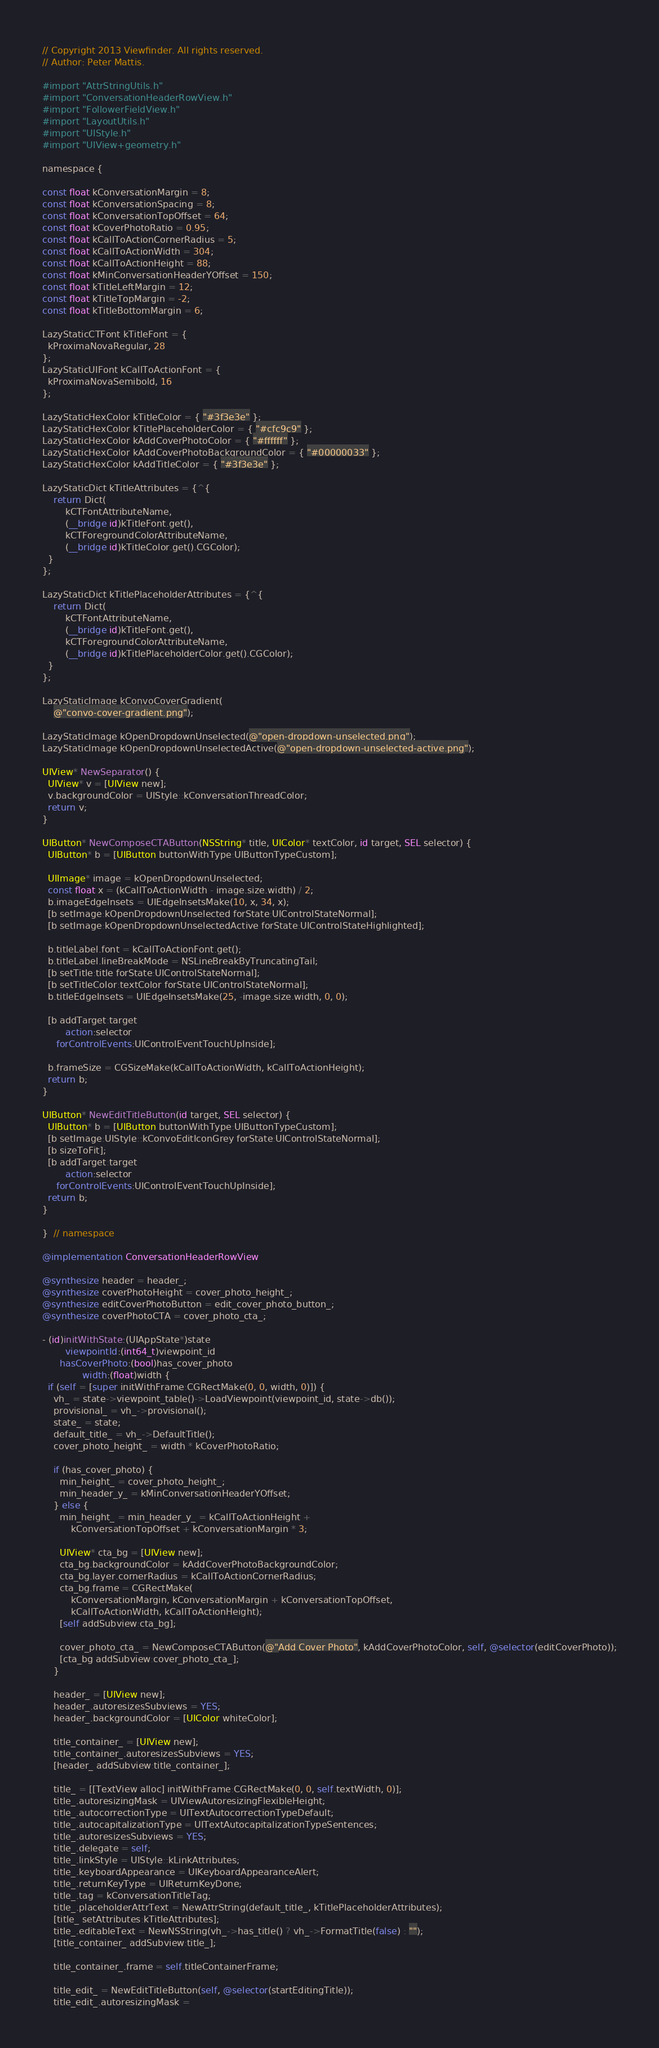Convert code to text. <code><loc_0><loc_0><loc_500><loc_500><_ObjectiveC_>// Copyright 2013 Viewfinder. All rights reserved.
// Author: Peter Mattis.

#import "AttrStringUtils.h"
#import "ConversationHeaderRowView.h"
#import "FollowerFieldView.h"
#import "LayoutUtils.h"
#import "UIStyle.h"
#import "UIView+geometry.h"

namespace {

const float kConversationMargin = 8;
const float kConversationSpacing = 8;
const float kConversationTopOffset = 64;
const float kCoverPhotoRatio = 0.95;
const float kCallToActionCornerRadius = 5;
const float kCallToActionWidth = 304;
const float kCallToActionHeight = 88;
const float kMinConversationHeaderYOffset = 150;
const float kTitleLeftMargin = 12;
const float kTitleTopMargin = -2;
const float kTitleBottomMargin = 6;

LazyStaticCTFont kTitleFont = {
  kProximaNovaRegular, 28
};
LazyStaticUIFont kCallToActionFont = {
  kProximaNovaSemibold, 16
};

LazyStaticHexColor kTitleColor = { "#3f3e3e" };
LazyStaticHexColor kTitlePlaceholderColor = { "#cfc9c9" };
LazyStaticHexColor kAddCoverPhotoColor = { "#ffffff" };
LazyStaticHexColor kAddCoverPhotoBackgroundColor = { "#00000033" };
LazyStaticHexColor kAddTitleColor = { "#3f3e3e" };

LazyStaticDict kTitleAttributes = {^{
    return Dict(
        kCTFontAttributeName,
        (__bridge id)kTitleFont.get(),
        kCTForegroundColorAttributeName,
        (__bridge id)kTitleColor.get().CGColor);
  }
};

LazyStaticDict kTitlePlaceholderAttributes = {^{
    return Dict(
        kCTFontAttributeName,
        (__bridge id)kTitleFont.get(),
        kCTForegroundColorAttributeName,
        (__bridge id)kTitlePlaceholderColor.get().CGColor);
  }
};

LazyStaticImage kConvoCoverGradient(
    @"convo-cover-gradient.png");

LazyStaticImage kOpenDropdownUnselected(@"open-dropdown-unselected.png");
LazyStaticImage kOpenDropdownUnselectedActive(@"open-dropdown-unselected-active.png");

UIView* NewSeparator() {
  UIView* v = [UIView new];
  v.backgroundColor = UIStyle::kConversationThreadColor;
  return v;
}

UIButton* NewComposeCTAButton(NSString* title, UIColor* textColor, id target, SEL selector) {
  UIButton* b = [UIButton buttonWithType:UIButtonTypeCustom];

  UIImage* image = kOpenDropdownUnselected;
  const float x = (kCallToActionWidth - image.size.width) / 2;
  b.imageEdgeInsets = UIEdgeInsetsMake(10, x, 34, x);
  [b setImage:kOpenDropdownUnselected forState:UIControlStateNormal];
  [b setImage:kOpenDropdownUnselectedActive forState:UIControlStateHighlighted];

  b.titleLabel.font = kCallToActionFont.get();
  b.titleLabel.lineBreakMode = NSLineBreakByTruncatingTail;
  [b setTitle:title forState:UIControlStateNormal];
  [b setTitleColor:textColor forState:UIControlStateNormal];
  b.titleEdgeInsets = UIEdgeInsetsMake(25, -image.size.width, 0, 0);

  [b addTarget:target
        action:selector
     forControlEvents:UIControlEventTouchUpInside];

  b.frameSize = CGSizeMake(kCallToActionWidth, kCallToActionHeight);
  return b;
}

UIButton* NewEditTitleButton(id target, SEL selector) {
  UIButton* b = [UIButton buttonWithType:UIButtonTypeCustom];
  [b setImage:UIStyle::kConvoEditIconGrey forState:UIControlStateNormal];
  [b sizeToFit];
  [b addTarget:target
        action:selector
     forControlEvents:UIControlEventTouchUpInside];
  return b;
}

}  // namespace

@implementation ConversationHeaderRowView

@synthesize header = header_;
@synthesize coverPhotoHeight = cover_photo_height_;
@synthesize editCoverPhotoButton = edit_cover_photo_button_;
@synthesize coverPhotoCTA = cover_photo_cta_;

- (id)initWithState:(UIAppState*)state
        viewpointId:(int64_t)viewpoint_id
      hasCoverPhoto:(bool)has_cover_photo
              width:(float)width {
  if (self = [super initWithFrame:CGRectMake(0, 0, width, 0)]) {
    vh_ = state->viewpoint_table()->LoadViewpoint(viewpoint_id, state->db());
    provisional_ = vh_->provisional();
    state_ = state;
    default_title_ = vh_->DefaultTitle();
    cover_photo_height_ = width * kCoverPhotoRatio;

    if (has_cover_photo) {
      min_height_ = cover_photo_height_;
      min_header_y_ = kMinConversationHeaderYOffset;
    } else {
      min_height_ = min_header_y_ = kCallToActionHeight +
          kConversationTopOffset + kConversationMargin * 3;

      UIView* cta_bg = [UIView new];
      cta_bg.backgroundColor = kAddCoverPhotoBackgroundColor;
      cta_bg.layer.cornerRadius = kCallToActionCornerRadius;
      cta_bg.frame = CGRectMake(
          kConversationMargin, kConversationMargin + kConversationTopOffset,
          kCallToActionWidth, kCallToActionHeight);
      [self addSubview:cta_bg];

      cover_photo_cta_ = NewComposeCTAButton(@"Add Cover Photo", kAddCoverPhotoColor, self, @selector(editCoverPhoto));
      [cta_bg addSubview:cover_photo_cta_];
    }

    header_ = [UIView new];
    header_.autoresizesSubviews = YES;
    header_.backgroundColor = [UIColor whiteColor];

    title_container_ = [UIView new];
    title_container_.autoresizesSubviews = YES;
    [header_ addSubview:title_container_];

    title_ = [[TextView alloc] initWithFrame:CGRectMake(0, 0, self.textWidth, 0)];
    title_.autoresizingMask = UIViewAutoresizingFlexibleHeight;
    title_.autocorrectionType = UITextAutocorrectionTypeDefault;
    title_.autocapitalizationType = UITextAutocapitalizationTypeSentences;
    title_.autoresizesSubviews = YES;
    title_.delegate = self;
    title_.linkStyle = UIStyle::kLinkAttributes;
    title_.keyboardAppearance = UIKeyboardAppearanceAlert;
    title_.returnKeyType = UIReturnKeyDone;
    title_.tag = kConversationTitleTag;
    title_.placeholderAttrText = NewAttrString(default_title_, kTitlePlaceholderAttributes);
    [title_ setAttributes:kTitleAttributes];
    title_.editableText = NewNSString(vh_->has_title() ? vh_->FormatTitle(false) : "");
    [title_container_ addSubview:title_];

    title_container_.frame = self.titleContainerFrame;

    title_edit_ = NewEditTitleButton(self, @selector(startEditingTitle));
    title_edit_.autoresizingMask =</code> 